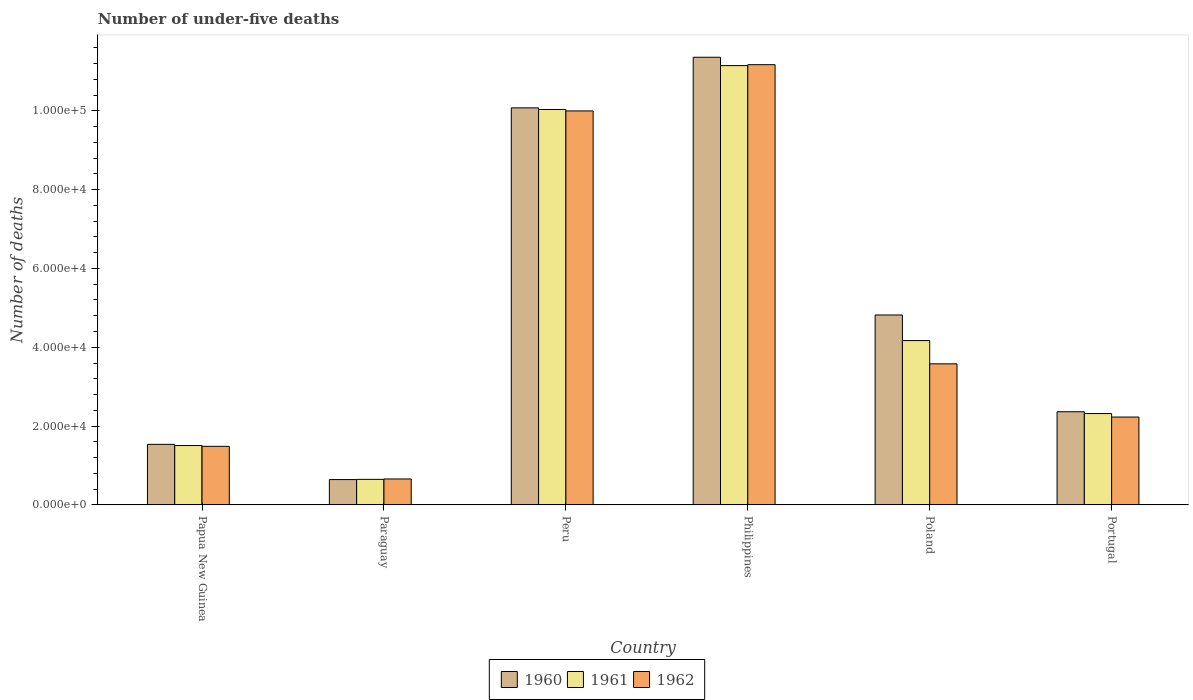How many groups of bars are there?
Provide a succinct answer. 6. Are the number of bars on each tick of the X-axis equal?
Your response must be concise. Yes. In how many cases, is the number of bars for a given country not equal to the number of legend labels?
Ensure brevity in your answer.  0. What is the number of under-five deaths in 1962 in Peru?
Your answer should be very brief. 1.00e+05. Across all countries, what is the maximum number of under-five deaths in 1960?
Offer a very short reply. 1.14e+05. Across all countries, what is the minimum number of under-five deaths in 1960?
Your answer should be compact. 6434. In which country was the number of under-five deaths in 1961 minimum?
Provide a succinct answer. Paraguay. What is the total number of under-five deaths in 1960 in the graph?
Your response must be concise. 3.08e+05. What is the difference between the number of under-five deaths in 1961 in Peru and that in Portugal?
Your answer should be very brief. 7.71e+04. What is the difference between the number of under-five deaths in 1962 in Paraguay and the number of under-five deaths in 1961 in Papua New Guinea?
Offer a terse response. -8478. What is the average number of under-five deaths in 1961 per country?
Offer a very short reply. 4.97e+04. What is the difference between the number of under-five deaths of/in 1960 and number of under-five deaths of/in 1961 in Portugal?
Offer a terse response. 457. What is the ratio of the number of under-five deaths in 1961 in Papua New Guinea to that in Philippines?
Give a very brief answer. 0.14. What is the difference between the highest and the second highest number of under-five deaths in 1960?
Keep it short and to the point. 1.28e+04. What is the difference between the highest and the lowest number of under-five deaths in 1960?
Make the answer very short. 1.07e+05. In how many countries, is the number of under-five deaths in 1960 greater than the average number of under-five deaths in 1960 taken over all countries?
Keep it short and to the point. 2. What does the 2nd bar from the left in Portugal represents?
Provide a succinct answer. 1961. Is it the case that in every country, the sum of the number of under-five deaths in 1960 and number of under-five deaths in 1962 is greater than the number of under-five deaths in 1961?
Ensure brevity in your answer.  Yes. How many bars are there?
Your response must be concise. 18. What is the difference between two consecutive major ticks on the Y-axis?
Your answer should be compact. 2.00e+04. Are the values on the major ticks of Y-axis written in scientific E-notation?
Give a very brief answer. Yes. Does the graph contain any zero values?
Offer a very short reply. No. Does the graph contain grids?
Provide a succinct answer. No. How many legend labels are there?
Ensure brevity in your answer.  3. What is the title of the graph?
Make the answer very short. Number of under-five deaths. Does "1996" appear as one of the legend labels in the graph?
Provide a short and direct response. No. What is the label or title of the Y-axis?
Ensure brevity in your answer.  Number of deaths. What is the Number of deaths in 1960 in Papua New Guinea?
Make the answer very short. 1.54e+04. What is the Number of deaths of 1961 in Papua New Guinea?
Ensure brevity in your answer.  1.51e+04. What is the Number of deaths of 1962 in Papua New Guinea?
Your response must be concise. 1.49e+04. What is the Number of deaths in 1960 in Paraguay?
Give a very brief answer. 6434. What is the Number of deaths of 1961 in Paraguay?
Provide a short and direct response. 6486. What is the Number of deaths in 1962 in Paraguay?
Offer a very short reply. 6590. What is the Number of deaths in 1960 in Peru?
Your answer should be very brief. 1.01e+05. What is the Number of deaths of 1961 in Peru?
Ensure brevity in your answer.  1.00e+05. What is the Number of deaths of 1962 in Peru?
Your answer should be compact. 1.00e+05. What is the Number of deaths of 1960 in Philippines?
Make the answer very short. 1.14e+05. What is the Number of deaths of 1961 in Philippines?
Make the answer very short. 1.11e+05. What is the Number of deaths of 1962 in Philippines?
Make the answer very short. 1.12e+05. What is the Number of deaths in 1960 in Poland?
Offer a very short reply. 4.82e+04. What is the Number of deaths in 1961 in Poland?
Your answer should be compact. 4.17e+04. What is the Number of deaths of 1962 in Poland?
Make the answer very short. 3.58e+04. What is the Number of deaths of 1960 in Portugal?
Give a very brief answer. 2.36e+04. What is the Number of deaths of 1961 in Portugal?
Your answer should be compact. 2.32e+04. What is the Number of deaths of 1962 in Portugal?
Your answer should be compact. 2.23e+04. Across all countries, what is the maximum Number of deaths in 1960?
Provide a succinct answer. 1.14e+05. Across all countries, what is the maximum Number of deaths in 1961?
Offer a very short reply. 1.11e+05. Across all countries, what is the maximum Number of deaths of 1962?
Your answer should be compact. 1.12e+05. Across all countries, what is the minimum Number of deaths in 1960?
Your answer should be very brief. 6434. Across all countries, what is the minimum Number of deaths in 1961?
Your answer should be compact. 6486. Across all countries, what is the minimum Number of deaths in 1962?
Provide a short and direct response. 6590. What is the total Number of deaths in 1960 in the graph?
Offer a terse response. 3.08e+05. What is the total Number of deaths in 1961 in the graph?
Offer a terse response. 2.98e+05. What is the total Number of deaths of 1962 in the graph?
Provide a short and direct response. 2.91e+05. What is the difference between the Number of deaths in 1960 in Papua New Guinea and that in Paraguay?
Your answer should be compact. 8936. What is the difference between the Number of deaths of 1961 in Papua New Guinea and that in Paraguay?
Offer a terse response. 8582. What is the difference between the Number of deaths of 1962 in Papua New Guinea and that in Paraguay?
Give a very brief answer. 8276. What is the difference between the Number of deaths in 1960 in Papua New Guinea and that in Peru?
Provide a succinct answer. -8.54e+04. What is the difference between the Number of deaths of 1961 in Papua New Guinea and that in Peru?
Your answer should be compact. -8.53e+04. What is the difference between the Number of deaths in 1962 in Papua New Guinea and that in Peru?
Offer a very short reply. -8.51e+04. What is the difference between the Number of deaths of 1960 in Papua New Guinea and that in Philippines?
Your response must be concise. -9.82e+04. What is the difference between the Number of deaths of 1961 in Papua New Guinea and that in Philippines?
Offer a very short reply. -9.64e+04. What is the difference between the Number of deaths in 1962 in Papua New Guinea and that in Philippines?
Offer a very short reply. -9.68e+04. What is the difference between the Number of deaths of 1960 in Papua New Guinea and that in Poland?
Provide a short and direct response. -3.28e+04. What is the difference between the Number of deaths of 1961 in Papua New Guinea and that in Poland?
Make the answer very short. -2.66e+04. What is the difference between the Number of deaths of 1962 in Papua New Guinea and that in Poland?
Keep it short and to the point. -2.09e+04. What is the difference between the Number of deaths of 1960 in Papua New Guinea and that in Portugal?
Provide a short and direct response. -8273. What is the difference between the Number of deaths of 1961 in Papua New Guinea and that in Portugal?
Your response must be concise. -8118. What is the difference between the Number of deaths in 1962 in Papua New Guinea and that in Portugal?
Your answer should be very brief. -7435. What is the difference between the Number of deaths in 1960 in Paraguay and that in Peru?
Your answer should be very brief. -9.43e+04. What is the difference between the Number of deaths of 1961 in Paraguay and that in Peru?
Your response must be concise. -9.38e+04. What is the difference between the Number of deaths of 1962 in Paraguay and that in Peru?
Keep it short and to the point. -9.34e+04. What is the difference between the Number of deaths of 1960 in Paraguay and that in Philippines?
Offer a very short reply. -1.07e+05. What is the difference between the Number of deaths of 1961 in Paraguay and that in Philippines?
Offer a very short reply. -1.05e+05. What is the difference between the Number of deaths of 1962 in Paraguay and that in Philippines?
Give a very brief answer. -1.05e+05. What is the difference between the Number of deaths in 1960 in Paraguay and that in Poland?
Provide a succinct answer. -4.18e+04. What is the difference between the Number of deaths in 1961 in Paraguay and that in Poland?
Your response must be concise. -3.52e+04. What is the difference between the Number of deaths of 1962 in Paraguay and that in Poland?
Provide a short and direct response. -2.92e+04. What is the difference between the Number of deaths of 1960 in Paraguay and that in Portugal?
Give a very brief answer. -1.72e+04. What is the difference between the Number of deaths in 1961 in Paraguay and that in Portugal?
Give a very brief answer. -1.67e+04. What is the difference between the Number of deaths in 1962 in Paraguay and that in Portugal?
Provide a short and direct response. -1.57e+04. What is the difference between the Number of deaths in 1960 in Peru and that in Philippines?
Keep it short and to the point. -1.28e+04. What is the difference between the Number of deaths in 1961 in Peru and that in Philippines?
Your response must be concise. -1.11e+04. What is the difference between the Number of deaths of 1962 in Peru and that in Philippines?
Your answer should be compact. -1.17e+04. What is the difference between the Number of deaths in 1960 in Peru and that in Poland?
Make the answer very short. 5.26e+04. What is the difference between the Number of deaths in 1961 in Peru and that in Poland?
Give a very brief answer. 5.86e+04. What is the difference between the Number of deaths of 1962 in Peru and that in Poland?
Offer a terse response. 6.42e+04. What is the difference between the Number of deaths of 1960 in Peru and that in Portugal?
Offer a terse response. 7.71e+04. What is the difference between the Number of deaths in 1961 in Peru and that in Portugal?
Offer a very short reply. 7.71e+04. What is the difference between the Number of deaths of 1962 in Peru and that in Portugal?
Give a very brief answer. 7.77e+04. What is the difference between the Number of deaths in 1960 in Philippines and that in Poland?
Ensure brevity in your answer.  6.54e+04. What is the difference between the Number of deaths of 1961 in Philippines and that in Poland?
Make the answer very short. 6.98e+04. What is the difference between the Number of deaths of 1962 in Philippines and that in Poland?
Keep it short and to the point. 7.59e+04. What is the difference between the Number of deaths in 1960 in Philippines and that in Portugal?
Provide a short and direct response. 8.99e+04. What is the difference between the Number of deaths in 1961 in Philippines and that in Portugal?
Keep it short and to the point. 8.83e+04. What is the difference between the Number of deaths in 1962 in Philippines and that in Portugal?
Ensure brevity in your answer.  8.94e+04. What is the difference between the Number of deaths of 1960 in Poland and that in Portugal?
Your response must be concise. 2.46e+04. What is the difference between the Number of deaths of 1961 in Poland and that in Portugal?
Give a very brief answer. 1.85e+04. What is the difference between the Number of deaths in 1962 in Poland and that in Portugal?
Provide a succinct answer. 1.35e+04. What is the difference between the Number of deaths in 1960 in Papua New Guinea and the Number of deaths in 1961 in Paraguay?
Offer a terse response. 8884. What is the difference between the Number of deaths in 1960 in Papua New Guinea and the Number of deaths in 1962 in Paraguay?
Offer a terse response. 8780. What is the difference between the Number of deaths of 1961 in Papua New Guinea and the Number of deaths of 1962 in Paraguay?
Give a very brief answer. 8478. What is the difference between the Number of deaths in 1960 in Papua New Guinea and the Number of deaths in 1961 in Peru?
Offer a very short reply. -8.50e+04. What is the difference between the Number of deaths in 1960 in Papua New Guinea and the Number of deaths in 1962 in Peru?
Make the answer very short. -8.46e+04. What is the difference between the Number of deaths of 1961 in Papua New Guinea and the Number of deaths of 1962 in Peru?
Provide a succinct answer. -8.49e+04. What is the difference between the Number of deaths of 1960 in Papua New Guinea and the Number of deaths of 1961 in Philippines?
Provide a succinct answer. -9.61e+04. What is the difference between the Number of deaths of 1960 in Papua New Guinea and the Number of deaths of 1962 in Philippines?
Your answer should be compact. -9.63e+04. What is the difference between the Number of deaths in 1961 in Papua New Guinea and the Number of deaths in 1962 in Philippines?
Offer a terse response. -9.66e+04. What is the difference between the Number of deaths of 1960 in Papua New Guinea and the Number of deaths of 1961 in Poland?
Provide a succinct answer. -2.63e+04. What is the difference between the Number of deaths in 1960 in Papua New Guinea and the Number of deaths in 1962 in Poland?
Ensure brevity in your answer.  -2.04e+04. What is the difference between the Number of deaths in 1961 in Papua New Guinea and the Number of deaths in 1962 in Poland?
Offer a very short reply. -2.07e+04. What is the difference between the Number of deaths of 1960 in Papua New Guinea and the Number of deaths of 1961 in Portugal?
Offer a very short reply. -7816. What is the difference between the Number of deaths in 1960 in Papua New Guinea and the Number of deaths in 1962 in Portugal?
Your answer should be compact. -6931. What is the difference between the Number of deaths in 1961 in Papua New Guinea and the Number of deaths in 1962 in Portugal?
Provide a short and direct response. -7233. What is the difference between the Number of deaths of 1960 in Paraguay and the Number of deaths of 1961 in Peru?
Offer a very short reply. -9.39e+04. What is the difference between the Number of deaths of 1960 in Paraguay and the Number of deaths of 1962 in Peru?
Keep it short and to the point. -9.35e+04. What is the difference between the Number of deaths in 1961 in Paraguay and the Number of deaths in 1962 in Peru?
Give a very brief answer. -9.35e+04. What is the difference between the Number of deaths of 1960 in Paraguay and the Number of deaths of 1961 in Philippines?
Give a very brief answer. -1.05e+05. What is the difference between the Number of deaths of 1960 in Paraguay and the Number of deaths of 1962 in Philippines?
Ensure brevity in your answer.  -1.05e+05. What is the difference between the Number of deaths in 1961 in Paraguay and the Number of deaths in 1962 in Philippines?
Your response must be concise. -1.05e+05. What is the difference between the Number of deaths of 1960 in Paraguay and the Number of deaths of 1961 in Poland?
Offer a terse response. -3.53e+04. What is the difference between the Number of deaths in 1960 in Paraguay and the Number of deaths in 1962 in Poland?
Offer a terse response. -2.94e+04. What is the difference between the Number of deaths in 1961 in Paraguay and the Number of deaths in 1962 in Poland?
Make the answer very short. -2.93e+04. What is the difference between the Number of deaths in 1960 in Paraguay and the Number of deaths in 1961 in Portugal?
Your response must be concise. -1.68e+04. What is the difference between the Number of deaths of 1960 in Paraguay and the Number of deaths of 1962 in Portugal?
Offer a very short reply. -1.59e+04. What is the difference between the Number of deaths of 1961 in Paraguay and the Number of deaths of 1962 in Portugal?
Make the answer very short. -1.58e+04. What is the difference between the Number of deaths of 1960 in Peru and the Number of deaths of 1961 in Philippines?
Ensure brevity in your answer.  -1.07e+04. What is the difference between the Number of deaths in 1960 in Peru and the Number of deaths in 1962 in Philippines?
Make the answer very short. -1.10e+04. What is the difference between the Number of deaths of 1961 in Peru and the Number of deaths of 1962 in Philippines?
Offer a terse response. -1.14e+04. What is the difference between the Number of deaths in 1960 in Peru and the Number of deaths in 1961 in Poland?
Your response must be concise. 5.90e+04. What is the difference between the Number of deaths in 1960 in Peru and the Number of deaths in 1962 in Poland?
Give a very brief answer. 6.50e+04. What is the difference between the Number of deaths in 1961 in Peru and the Number of deaths in 1962 in Poland?
Ensure brevity in your answer.  6.45e+04. What is the difference between the Number of deaths in 1960 in Peru and the Number of deaths in 1961 in Portugal?
Offer a very short reply. 7.76e+04. What is the difference between the Number of deaths in 1960 in Peru and the Number of deaths in 1962 in Portugal?
Give a very brief answer. 7.84e+04. What is the difference between the Number of deaths in 1961 in Peru and the Number of deaths in 1962 in Portugal?
Provide a short and direct response. 7.80e+04. What is the difference between the Number of deaths of 1960 in Philippines and the Number of deaths of 1961 in Poland?
Provide a short and direct response. 7.19e+04. What is the difference between the Number of deaths in 1960 in Philippines and the Number of deaths in 1962 in Poland?
Keep it short and to the point. 7.78e+04. What is the difference between the Number of deaths of 1961 in Philippines and the Number of deaths of 1962 in Poland?
Ensure brevity in your answer.  7.57e+04. What is the difference between the Number of deaths in 1960 in Philippines and the Number of deaths in 1961 in Portugal?
Your answer should be compact. 9.04e+04. What is the difference between the Number of deaths of 1960 in Philippines and the Number of deaths of 1962 in Portugal?
Your response must be concise. 9.13e+04. What is the difference between the Number of deaths of 1961 in Philippines and the Number of deaths of 1962 in Portugal?
Your answer should be very brief. 8.92e+04. What is the difference between the Number of deaths of 1960 in Poland and the Number of deaths of 1961 in Portugal?
Your response must be concise. 2.50e+04. What is the difference between the Number of deaths of 1960 in Poland and the Number of deaths of 1962 in Portugal?
Give a very brief answer. 2.59e+04. What is the difference between the Number of deaths of 1961 in Poland and the Number of deaths of 1962 in Portugal?
Ensure brevity in your answer.  1.94e+04. What is the average Number of deaths in 1960 per country?
Your response must be concise. 5.13e+04. What is the average Number of deaths in 1961 per country?
Ensure brevity in your answer.  4.97e+04. What is the average Number of deaths in 1962 per country?
Your answer should be compact. 4.85e+04. What is the difference between the Number of deaths in 1960 and Number of deaths in 1961 in Papua New Guinea?
Provide a short and direct response. 302. What is the difference between the Number of deaths of 1960 and Number of deaths of 1962 in Papua New Guinea?
Offer a terse response. 504. What is the difference between the Number of deaths of 1961 and Number of deaths of 1962 in Papua New Guinea?
Offer a very short reply. 202. What is the difference between the Number of deaths in 1960 and Number of deaths in 1961 in Paraguay?
Keep it short and to the point. -52. What is the difference between the Number of deaths of 1960 and Number of deaths of 1962 in Paraguay?
Keep it short and to the point. -156. What is the difference between the Number of deaths of 1961 and Number of deaths of 1962 in Paraguay?
Your answer should be compact. -104. What is the difference between the Number of deaths in 1960 and Number of deaths in 1961 in Peru?
Ensure brevity in your answer.  416. What is the difference between the Number of deaths of 1960 and Number of deaths of 1962 in Peru?
Your answer should be very brief. 778. What is the difference between the Number of deaths of 1961 and Number of deaths of 1962 in Peru?
Keep it short and to the point. 362. What is the difference between the Number of deaths in 1960 and Number of deaths in 1961 in Philippines?
Your answer should be compact. 2118. What is the difference between the Number of deaths in 1960 and Number of deaths in 1962 in Philippines?
Your answer should be compact. 1883. What is the difference between the Number of deaths of 1961 and Number of deaths of 1962 in Philippines?
Provide a short and direct response. -235. What is the difference between the Number of deaths of 1960 and Number of deaths of 1961 in Poland?
Your answer should be compact. 6494. What is the difference between the Number of deaths of 1960 and Number of deaths of 1962 in Poland?
Ensure brevity in your answer.  1.24e+04. What is the difference between the Number of deaths of 1961 and Number of deaths of 1962 in Poland?
Your answer should be very brief. 5902. What is the difference between the Number of deaths of 1960 and Number of deaths of 1961 in Portugal?
Your answer should be very brief. 457. What is the difference between the Number of deaths of 1960 and Number of deaths of 1962 in Portugal?
Your answer should be very brief. 1342. What is the difference between the Number of deaths in 1961 and Number of deaths in 1962 in Portugal?
Your response must be concise. 885. What is the ratio of the Number of deaths in 1960 in Papua New Guinea to that in Paraguay?
Provide a short and direct response. 2.39. What is the ratio of the Number of deaths in 1961 in Papua New Guinea to that in Paraguay?
Your answer should be very brief. 2.32. What is the ratio of the Number of deaths in 1962 in Papua New Guinea to that in Paraguay?
Keep it short and to the point. 2.26. What is the ratio of the Number of deaths in 1960 in Papua New Guinea to that in Peru?
Ensure brevity in your answer.  0.15. What is the ratio of the Number of deaths in 1961 in Papua New Guinea to that in Peru?
Your response must be concise. 0.15. What is the ratio of the Number of deaths in 1962 in Papua New Guinea to that in Peru?
Your response must be concise. 0.15. What is the ratio of the Number of deaths in 1960 in Papua New Guinea to that in Philippines?
Offer a terse response. 0.14. What is the ratio of the Number of deaths of 1961 in Papua New Guinea to that in Philippines?
Provide a succinct answer. 0.14. What is the ratio of the Number of deaths in 1962 in Papua New Guinea to that in Philippines?
Your answer should be compact. 0.13. What is the ratio of the Number of deaths of 1960 in Papua New Guinea to that in Poland?
Give a very brief answer. 0.32. What is the ratio of the Number of deaths of 1961 in Papua New Guinea to that in Poland?
Offer a very short reply. 0.36. What is the ratio of the Number of deaths of 1962 in Papua New Guinea to that in Poland?
Offer a terse response. 0.42. What is the ratio of the Number of deaths in 1960 in Papua New Guinea to that in Portugal?
Offer a terse response. 0.65. What is the ratio of the Number of deaths in 1961 in Papua New Guinea to that in Portugal?
Your response must be concise. 0.65. What is the ratio of the Number of deaths in 1962 in Papua New Guinea to that in Portugal?
Provide a succinct answer. 0.67. What is the ratio of the Number of deaths of 1960 in Paraguay to that in Peru?
Keep it short and to the point. 0.06. What is the ratio of the Number of deaths of 1961 in Paraguay to that in Peru?
Ensure brevity in your answer.  0.06. What is the ratio of the Number of deaths in 1962 in Paraguay to that in Peru?
Offer a very short reply. 0.07. What is the ratio of the Number of deaths of 1960 in Paraguay to that in Philippines?
Your answer should be very brief. 0.06. What is the ratio of the Number of deaths in 1961 in Paraguay to that in Philippines?
Keep it short and to the point. 0.06. What is the ratio of the Number of deaths of 1962 in Paraguay to that in Philippines?
Give a very brief answer. 0.06. What is the ratio of the Number of deaths of 1960 in Paraguay to that in Poland?
Make the answer very short. 0.13. What is the ratio of the Number of deaths of 1961 in Paraguay to that in Poland?
Provide a succinct answer. 0.16. What is the ratio of the Number of deaths in 1962 in Paraguay to that in Poland?
Your answer should be very brief. 0.18. What is the ratio of the Number of deaths in 1960 in Paraguay to that in Portugal?
Ensure brevity in your answer.  0.27. What is the ratio of the Number of deaths of 1961 in Paraguay to that in Portugal?
Provide a succinct answer. 0.28. What is the ratio of the Number of deaths in 1962 in Paraguay to that in Portugal?
Provide a short and direct response. 0.3. What is the ratio of the Number of deaths of 1960 in Peru to that in Philippines?
Keep it short and to the point. 0.89. What is the ratio of the Number of deaths of 1961 in Peru to that in Philippines?
Keep it short and to the point. 0.9. What is the ratio of the Number of deaths in 1962 in Peru to that in Philippines?
Provide a succinct answer. 0.9. What is the ratio of the Number of deaths of 1960 in Peru to that in Poland?
Make the answer very short. 2.09. What is the ratio of the Number of deaths of 1961 in Peru to that in Poland?
Your answer should be very brief. 2.41. What is the ratio of the Number of deaths of 1962 in Peru to that in Poland?
Offer a terse response. 2.79. What is the ratio of the Number of deaths in 1960 in Peru to that in Portugal?
Provide a short and direct response. 4.26. What is the ratio of the Number of deaths of 1961 in Peru to that in Portugal?
Give a very brief answer. 4.33. What is the ratio of the Number of deaths of 1962 in Peru to that in Portugal?
Your answer should be very brief. 4.48. What is the ratio of the Number of deaths of 1960 in Philippines to that in Poland?
Provide a short and direct response. 2.36. What is the ratio of the Number of deaths of 1961 in Philippines to that in Poland?
Your response must be concise. 2.67. What is the ratio of the Number of deaths of 1962 in Philippines to that in Poland?
Give a very brief answer. 3.12. What is the ratio of the Number of deaths in 1960 in Philippines to that in Portugal?
Keep it short and to the point. 4.8. What is the ratio of the Number of deaths of 1961 in Philippines to that in Portugal?
Ensure brevity in your answer.  4.81. What is the ratio of the Number of deaths in 1962 in Philippines to that in Portugal?
Offer a terse response. 5.01. What is the ratio of the Number of deaths of 1960 in Poland to that in Portugal?
Your answer should be very brief. 2.04. What is the ratio of the Number of deaths in 1961 in Poland to that in Portugal?
Keep it short and to the point. 1.8. What is the ratio of the Number of deaths in 1962 in Poland to that in Portugal?
Offer a terse response. 1.61. What is the difference between the highest and the second highest Number of deaths of 1960?
Give a very brief answer. 1.28e+04. What is the difference between the highest and the second highest Number of deaths in 1961?
Make the answer very short. 1.11e+04. What is the difference between the highest and the second highest Number of deaths of 1962?
Provide a succinct answer. 1.17e+04. What is the difference between the highest and the lowest Number of deaths in 1960?
Offer a very short reply. 1.07e+05. What is the difference between the highest and the lowest Number of deaths in 1961?
Give a very brief answer. 1.05e+05. What is the difference between the highest and the lowest Number of deaths of 1962?
Make the answer very short. 1.05e+05. 